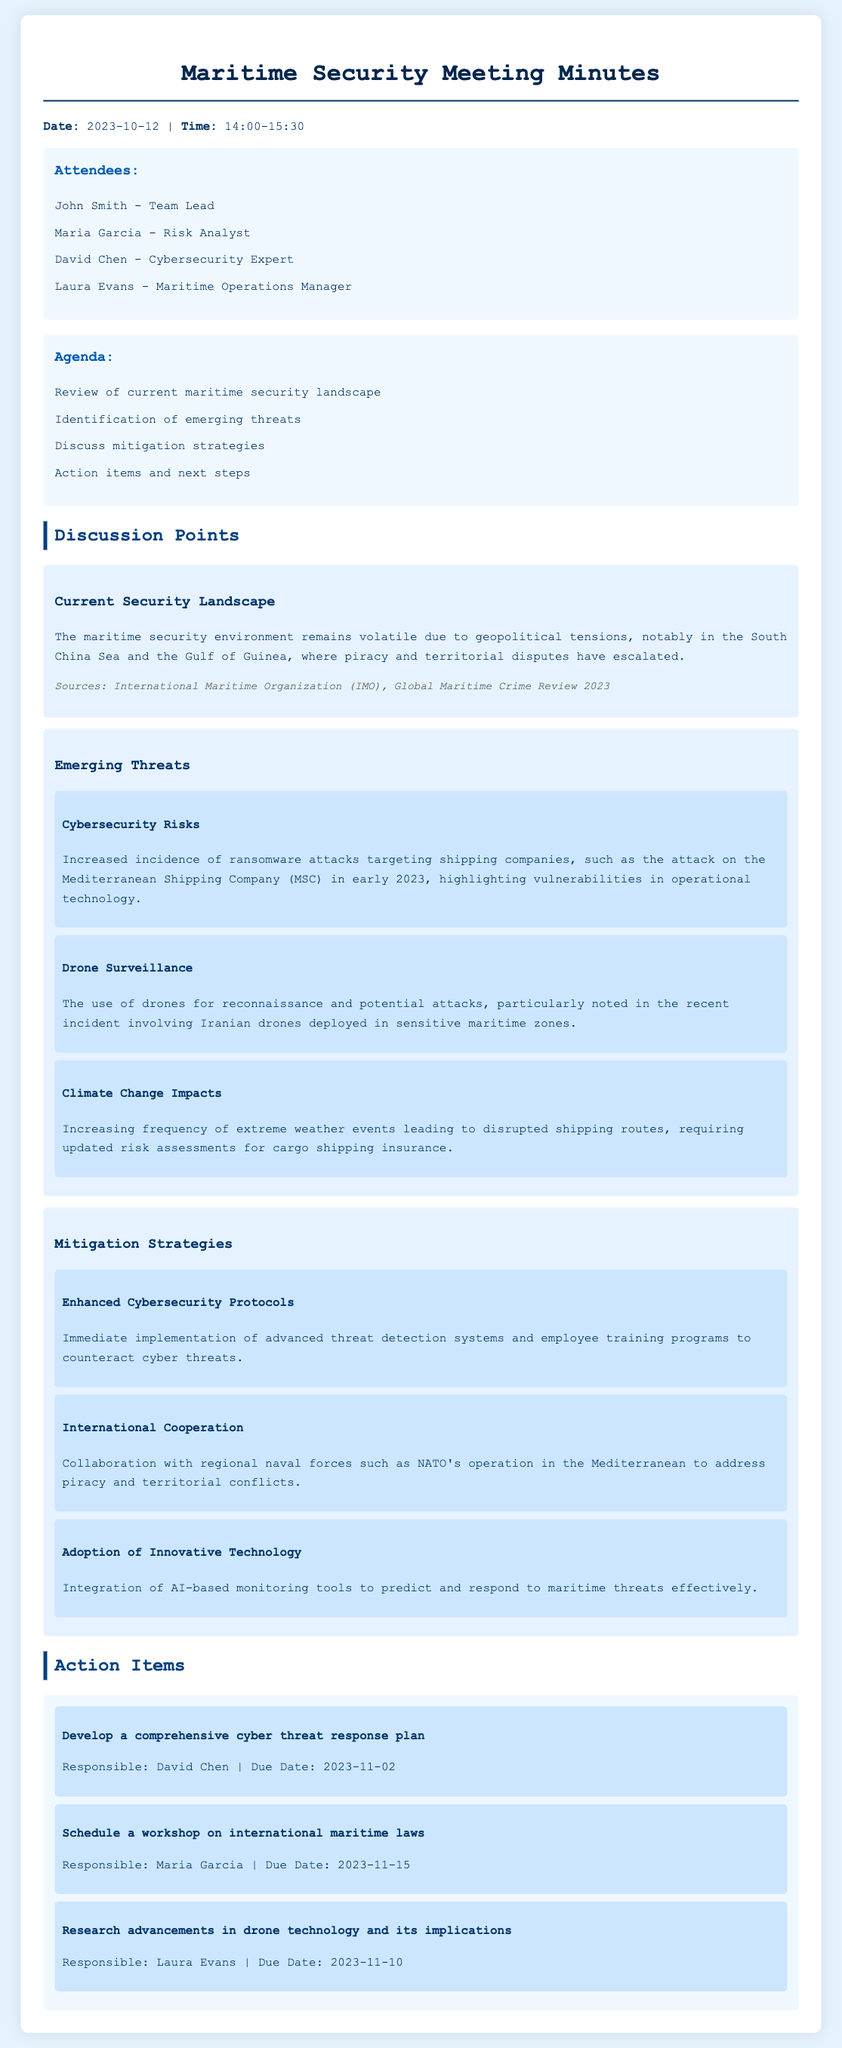What is the date of the meeting? The meeting took place on October 12, 2023, as stated in the document.
Answer: October 12, 2023 Who is the Team Lead? The document lists John Smith as the Team Lead among the attendees.
Answer: John Smith What emerging threat relates to weather? The discussion mentions climate change impacts as an emerging threat affecting shipping routes.
Answer: Climate Change Impacts What is one mitigation strategy discussed? The document outlines several strategies, including enhanced cybersecurity protocols.
Answer: Enhanced Cybersecurity Protocols Who is responsible for developing the cyber threat response plan? David Chen is assigned responsibility for developing the plan, as indicated in the action items.
Answer: David Chen When is the due date for the drone technology research? The due date for researching advancements in drone technology is mentioned in the action items.
Answer: November 10, 2023 What geographic area has seen increased piracy? The South China Sea is noted for escalating piracy and territorial disputes in the current security landscape.
Answer: South China Sea How long was the meeting? The meeting is documented as taking place from 14:00 to 15:30, indicating its duration.
Answer: 1 hour 30 minutes 